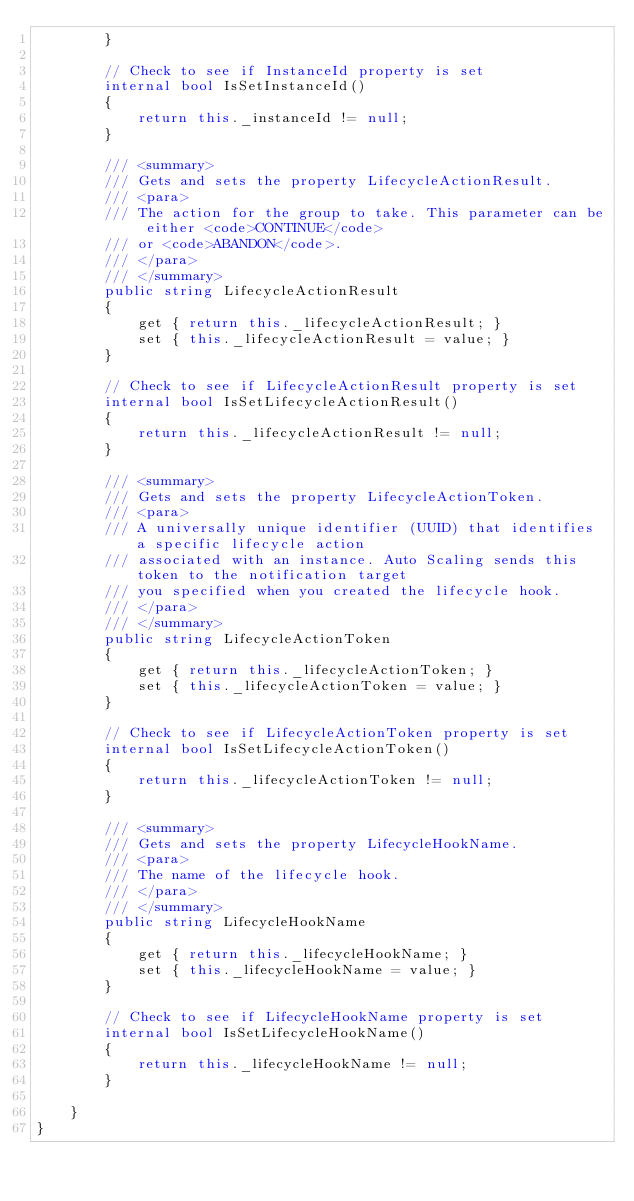<code> <loc_0><loc_0><loc_500><loc_500><_C#_>        }

        // Check to see if InstanceId property is set
        internal bool IsSetInstanceId()
        {
            return this._instanceId != null;
        }

        /// <summary>
        /// Gets and sets the property LifecycleActionResult. 
        /// <para>
        /// The action for the group to take. This parameter can be either <code>CONTINUE</code>
        /// or <code>ABANDON</code>.
        /// </para>
        /// </summary>
        public string LifecycleActionResult
        {
            get { return this._lifecycleActionResult; }
            set { this._lifecycleActionResult = value; }
        }

        // Check to see if LifecycleActionResult property is set
        internal bool IsSetLifecycleActionResult()
        {
            return this._lifecycleActionResult != null;
        }

        /// <summary>
        /// Gets and sets the property LifecycleActionToken. 
        /// <para>
        /// A universally unique identifier (UUID) that identifies a specific lifecycle action
        /// associated with an instance. Auto Scaling sends this token to the notification target
        /// you specified when you created the lifecycle hook.
        /// </para>
        /// </summary>
        public string LifecycleActionToken
        {
            get { return this._lifecycleActionToken; }
            set { this._lifecycleActionToken = value; }
        }

        // Check to see if LifecycleActionToken property is set
        internal bool IsSetLifecycleActionToken()
        {
            return this._lifecycleActionToken != null;
        }

        /// <summary>
        /// Gets and sets the property LifecycleHookName. 
        /// <para>
        /// The name of the lifecycle hook.
        /// </para>
        /// </summary>
        public string LifecycleHookName
        {
            get { return this._lifecycleHookName; }
            set { this._lifecycleHookName = value; }
        }

        // Check to see if LifecycleHookName property is set
        internal bool IsSetLifecycleHookName()
        {
            return this._lifecycleHookName != null;
        }

    }
}</code> 